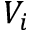Convert formula to latex. <formula><loc_0><loc_0><loc_500><loc_500>V _ { i }</formula> 